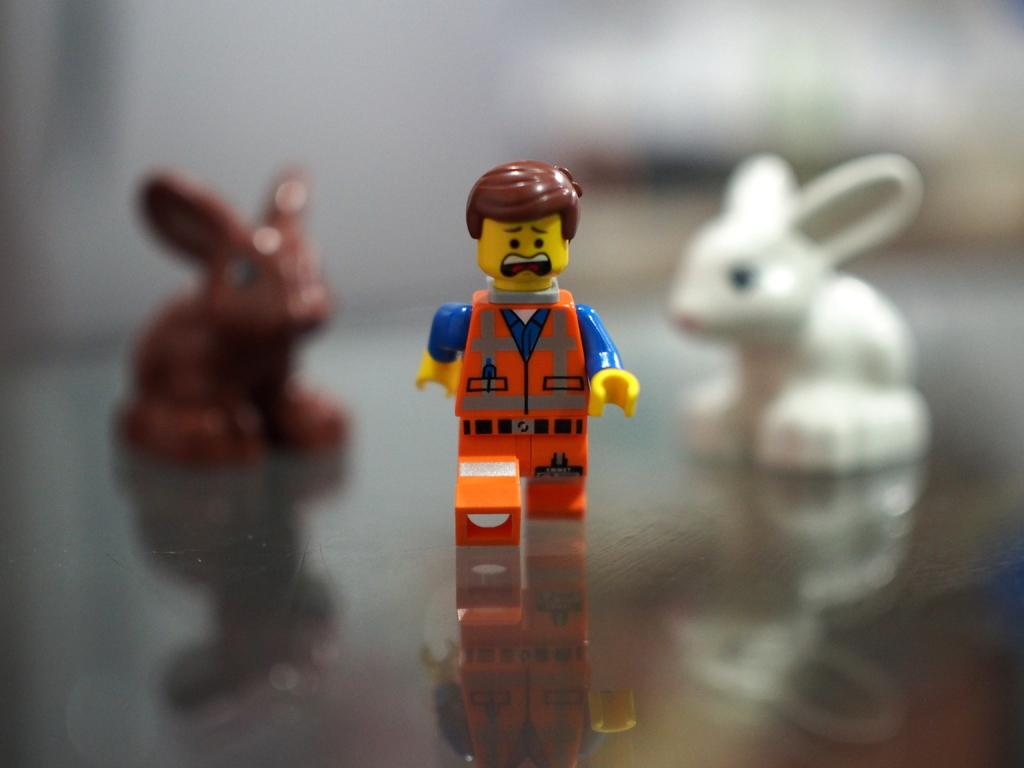How many toys are present in the image? There are three toys in the image. Can you describe the appearance of one of the toys? One of the toys is in the shape of a person. What is the shape of another toy in the image? One of the toys is in the shape of a rabbit. Where is the dock located in the image? There is no dock present in the image. What type of drawer can be seen in the image? There is no drawer present in the image. 